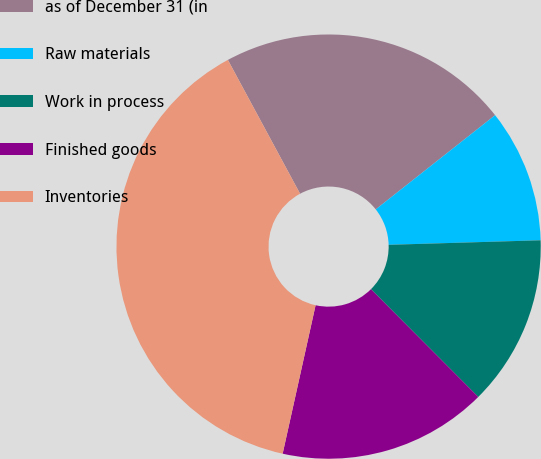Convert chart to OTSL. <chart><loc_0><loc_0><loc_500><loc_500><pie_chart><fcel>as of December 31 (in<fcel>Raw materials<fcel>Work in process<fcel>Finished goods<fcel>Inventories<nl><fcel>22.24%<fcel>10.16%<fcel>13.01%<fcel>15.94%<fcel>38.65%<nl></chart> 